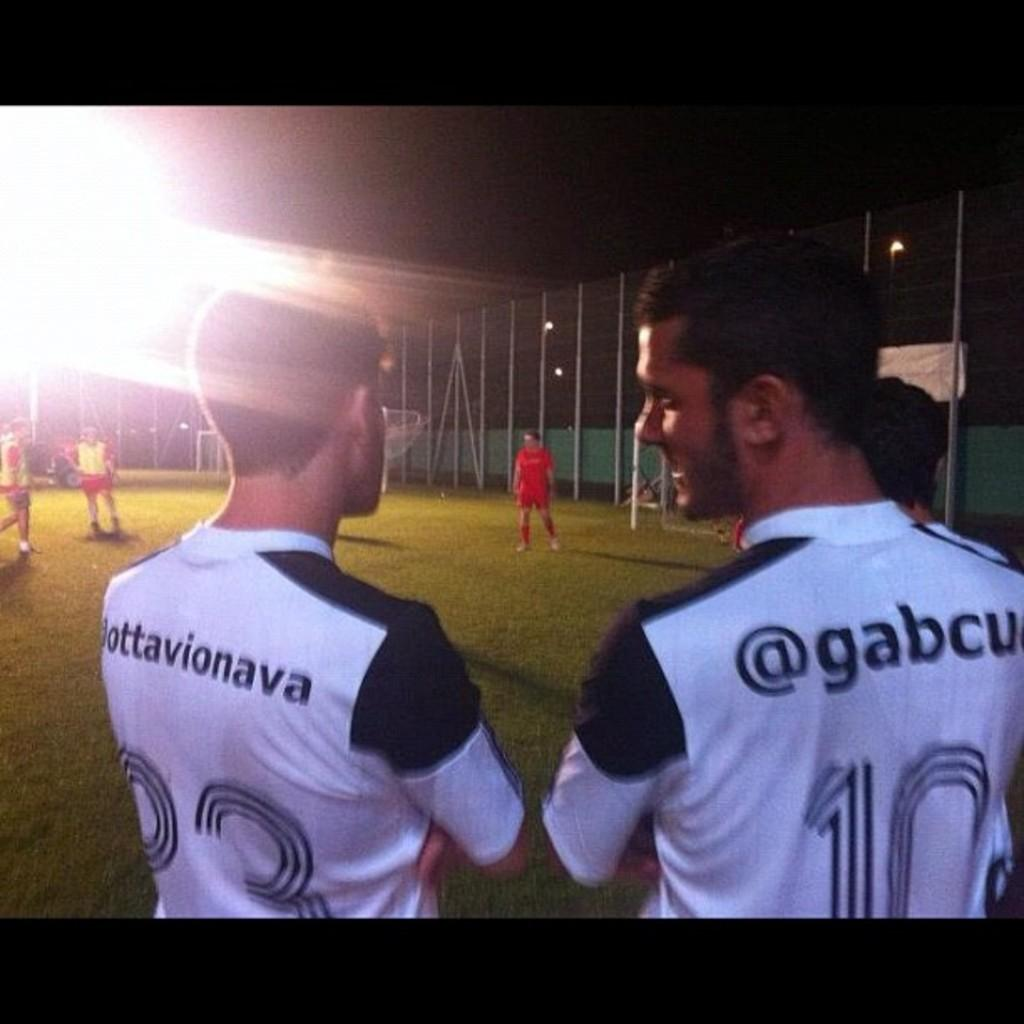<image>
Render a clear and concise summary of the photo. Player with jersey number 23 talking to another man with the jersey 10. 